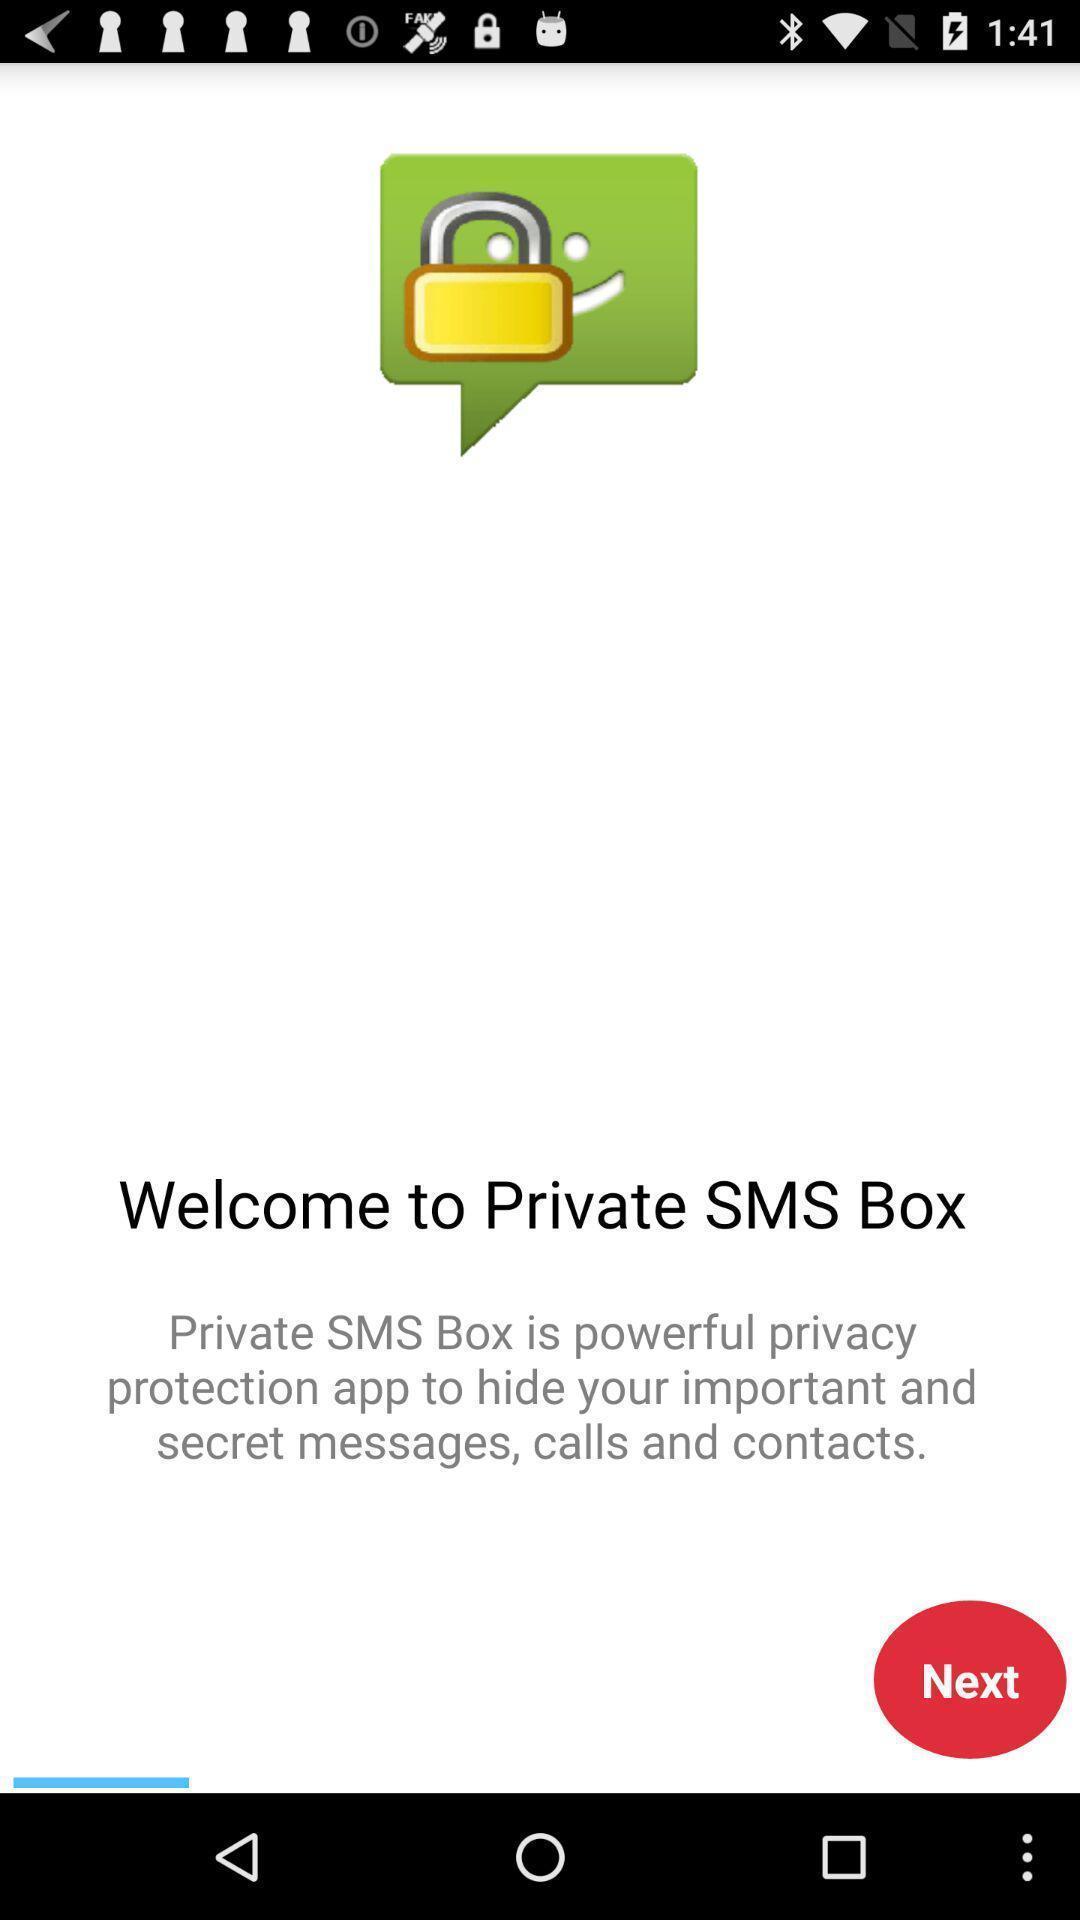Explain what's happening in this screen capture. Welcome page of messaging application. 